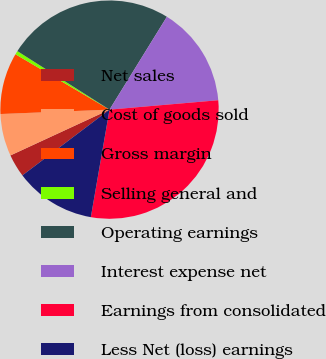Convert chart to OTSL. <chart><loc_0><loc_0><loc_500><loc_500><pie_chart><fcel>Net sales<fcel>Cost of goods sold<fcel>Gross margin<fcel>Selling general and<fcel>Operating earnings<fcel>Interest expense net<fcel>Earnings from consolidated<fcel>Less Net (loss) earnings<nl><fcel>3.4%<fcel>6.25%<fcel>9.11%<fcel>0.54%<fcel>24.8%<fcel>14.82%<fcel>29.11%<fcel>11.97%<nl></chart> 